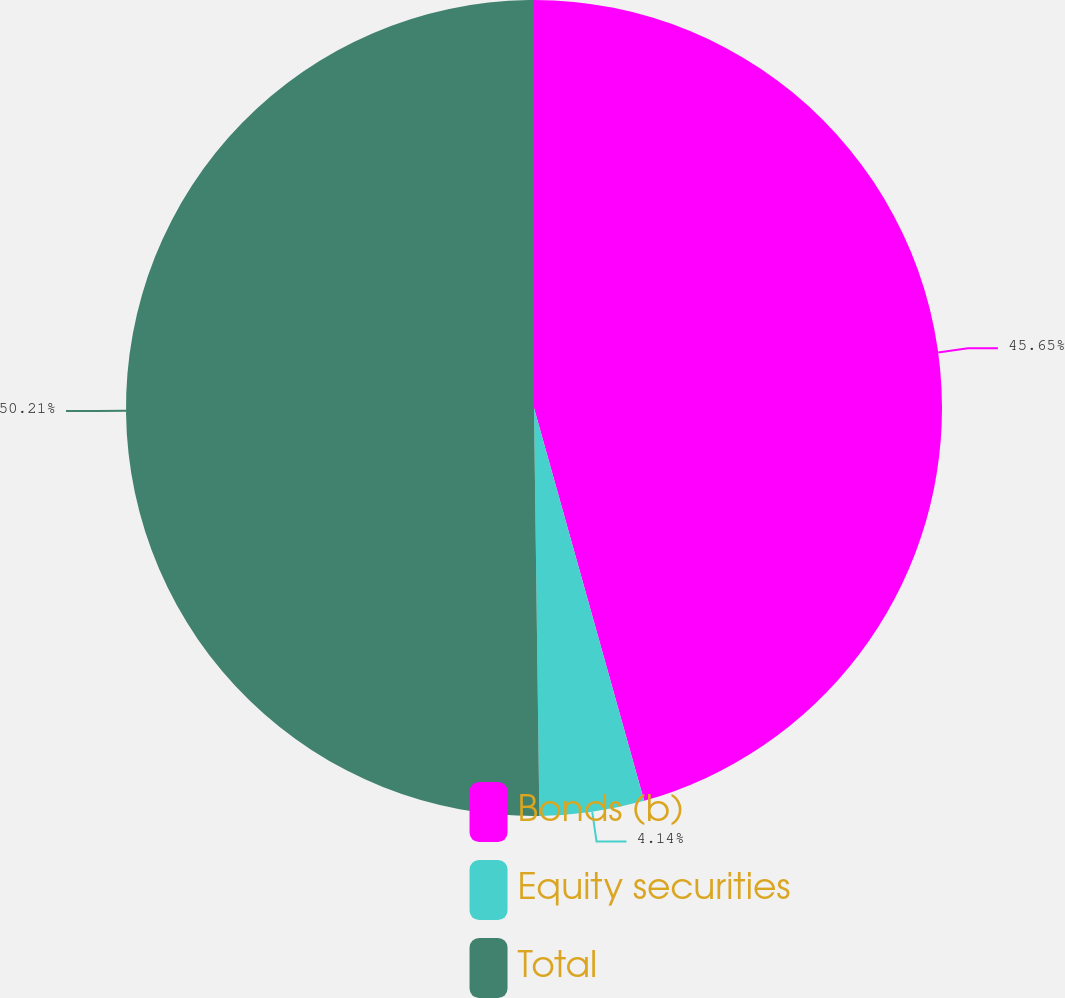<chart> <loc_0><loc_0><loc_500><loc_500><pie_chart><fcel>Bonds (b)<fcel>Equity securities<fcel>Total<nl><fcel>45.65%<fcel>4.14%<fcel>50.21%<nl></chart> 